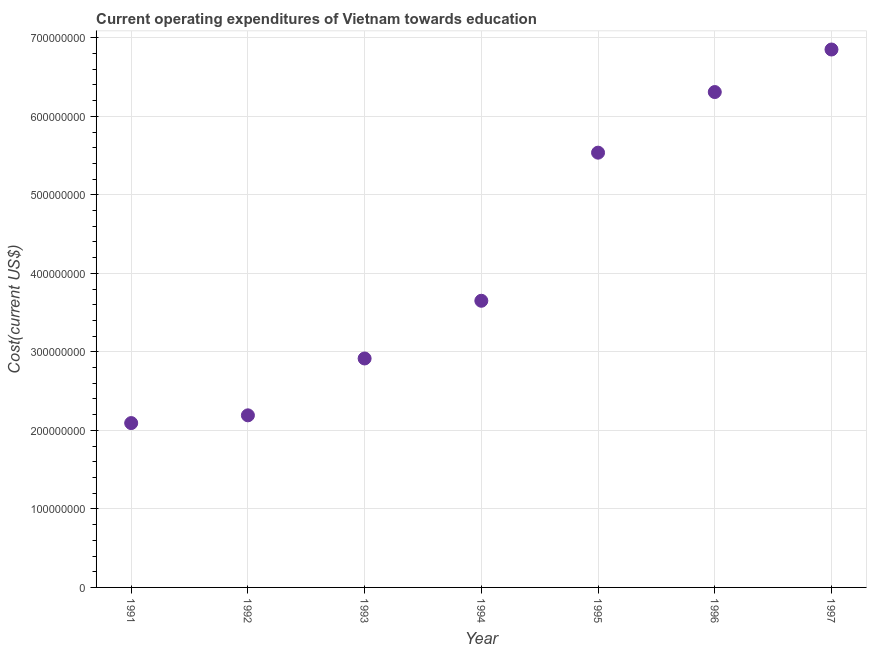What is the education expenditure in 1992?
Offer a terse response. 2.19e+08. Across all years, what is the maximum education expenditure?
Keep it short and to the point. 6.85e+08. Across all years, what is the minimum education expenditure?
Your answer should be very brief. 2.09e+08. In which year was the education expenditure maximum?
Your answer should be very brief. 1997. In which year was the education expenditure minimum?
Offer a very short reply. 1991. What is the sum of the education expenditure?
Offer a terse response. 2.96e+09. What is the difference between the education expenditure in 1992 and 1996?
Provide a short and direct response. -4.12e+08. What is the average education expenditure per year?
Make the answer very short. 4.22e+08. What is the median education expenditure?
Ensure brevity in your answer.  3.65e+08. Do a majority of the years between 1992 and 1996 (inclusive) have education expenditure greater than 320000000 US$?
Give a very brief answer. Yes. What is the ratio of the education expenditure in 1992 to that in 1997?
Provide a succinct answer. 0.32. Is the education expenditure in 1991 less than that in 1995?
Provide a succinct answer. Yes. Is the difference between the education expenditure in 1994 and 1997 greater than the difference between any two years?
Provide a short and direct response. No. What is the difference between the highest and the second highest education expenditure?
Offer a terse response. 5.42e+07. What is the difference between the highest and the lowest education expenditure?
Your response must be concise. 4.76e+08. Does the education expenditure monotonically increase over the years?
Ensure brevity in your answer.  Yes. Are the values on the major ticks of Y-axis written in scientific E-notation?
Keep it short and to the point. No. Does the graph contain any zero values?
Provide a succinct answer. No. What is the title of the graph?
Your answer should be compact. Current operating expenditures of Vietnam towards education. What is the label or title of the Y-axis?
Provide a succinct answer. Cost(current US$). What is the Cost(current US$) in 1991?
Offer a very short reply. 2.09e+08. What is the Cost(current US$) in 1992?
Offer a very short reply. 2.19e+08. What is the Cost(current US$) in 1993?
Your answer should be compact. 2.92e+08. What is the Cost(current US$) in 1994?
Offer a terse response. 3.65e+08. What is the Cost(current US$) in 1995?
Keep it short and to the point. 5.54e+08. What is the Cost(current US$) in 1996?
Provide a succinct answer. 6.31e+08. What is the Cost(current US$) in 1997?
Your answer should be very brief. 6.85e+08. What is the difference between the Cost(current US$) in 1991 and 1992?
Provide a short and direct response. -9.86e+06. What is the difference between the Cost(current US$) in 1991 and 1993?
Your answer should be very brief. -8.23e+07. What is the difference between the Cost(current US$) in 1991 and 1994?
Your answer should be very brief. -1.56e+08. What is the difference between the Cost(current US$) in 1991 and 1995?
Your response must be concise. -3.44e+08. What is the difference between the Cost(current US$) in 1991 and 1996?
Your response must be concise. -4.22e+08. What is the difference between the Cost(current US$) in 1991 and 1997?
Offer a very short reply. -4.76e+08. What is the difference between the Cost(current US$) in 1992 and 1993?
Offer a terse response. -7.24e+07. What is the difference between the Cost(current US$) in 1992 and 1994?
Provide a short and direct response. -1.46e+08. What is the difference between the Cost(current US$) in 1992 and 1995?
Offer a terse response. -3.35e+08. What is the difference between the Cost(current US$) in 1992 and 1996?
Your answer should be compact. -4.12e+08. What is the difference between the Cost(current US$) in 1992 and 1997?
Provide a short and direct response. -4.66e+08. What is the difference between the Cost(current US$) in 1993 and 1994?
Offer a terse response. -7.35e+07. What is the difference between the Cost(current US$) in 1993 and 1995?
Ensure brevity in your answer.  -2.62e+08. What is the difference between the Cost(current US$) in 1993 and 1996?
Your answer should be very brief. -3.39e+08. What is the difference between the Cost(current US$) in 1993 and 1997?
Your response must be concise. -3.94e+08. What is the difference between the Cost(current US$) in 1994 and 1995?
Your response must be concise. -1.89e+08. What is the difference between the Cost(current US$) in 1994 and 1996?
Your answer should be very brief. -2.66e+08. What is the difference between the Cost(current US$) in 1994 and 1997?
Your response must be concise. -3.20e+08. What is the difference between the Cost(current US$) in 1995 and 1996?
Offer a very short reply. -7.72e+07. What is the difference between the Cost(current US$) in 1995 and 1997?
Your response must be concise. -1.31e+08. What is the difference between the Cost(current US$) in 1996 and 1997?
Keep it short and to the point. -5.42e+07. What is the ratio of the Cost(current US$) in 1991 to that in 1992?
Ensure brevity in your answer.  0.95. What is the ratio of the Cost(current US$) in 1991 to that in 1993?
Offer a terse response. 0.72. What is the ratio of the Cost(current US$) in 1991 to that in 1994?
Provide a short and direct response. 0.57. What is the ratio of the Cost(current US$) in 1991 to that in 1995?
Give a very brief answer. 0.38. What is the ratio of the Cost(current US$) in 1991 to that in 1996?
Offer a terse response. 0.33. What is the ratio of the Cost(current US$) in 1991 to that in 1997?
Offer a very short reply. 0.31. What is the ratio of the Cost(current US$) in 1992 to that in 1993?
Keep it short and to the point. 0.75. What is the ratio of the Cost(current US$) in 1992 to that in 1995?
Your answer should be very brief. 0.4. What is the ratio of the Cost(current US$) in 1992 to that in 1996?
Offer a terse response. 0.35. What is the ratio of the Cost(current US$) in 1992 to that in 1997?
Offer a very short reply. 0.32. What is the ratio of the Cost(current US$) in 1993 to that in 1994?
Your response must be concise. 0.8. What is the ratio of the Cost(current US$) in 1993 to that in 1995?
Give a very brief answer. 0.53. What is the ratio of the Cost(current US$) in 1993 to that in 1996?
Your answer should be compact. 0.46. What is the ratio of the Cost(current US$) in 1993 to that in 1997?
Your answer should be very brief. 0.43. What is the ratio of the Cost(current US$) in 1994 to that in 1995?
Offer a very short reply. 0.66. What is the ratio of the Cost(current US$) in 1994 to that in 1996?
Offer a terse response. 0.58. What is the ratio of the Cost(current US$) in 1994 to that in 1997?
Provide a succinct answer. 0.53. What is the ratio of the Cost(current US$) in 1995 to that in 1996?
Offer a very short reply. 0.88. What is the ratio of the Cost(current US$) in 1995 to that in 1997?
Keep it short and to the point. 0.81. What is the ratio of the Cost(current US$) in 1996 to that in 1997?
Your answer should be compact. 0.92. 